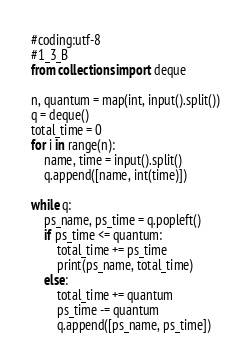Convert code to text. <code><loc_0><loc_0><loc_500><loc_500><_Python_>#coding:utf-8
#1_3_B
from collections import deque

n, quantum = map(int, input().split())
q = deque()
total_time = 0
for i in range(n):
    name, time = input().split()
    q.append([name, int(time)])

while q:
    ps_name, ps_time = q.popleft()
    if ps_time <= quantum:
        total_time += ps_time
        print(ps_name, total_time)
    else:
        total_time += quantum
        ps_time -= quantum
        q.append([ps_name, ps_time])</code> 